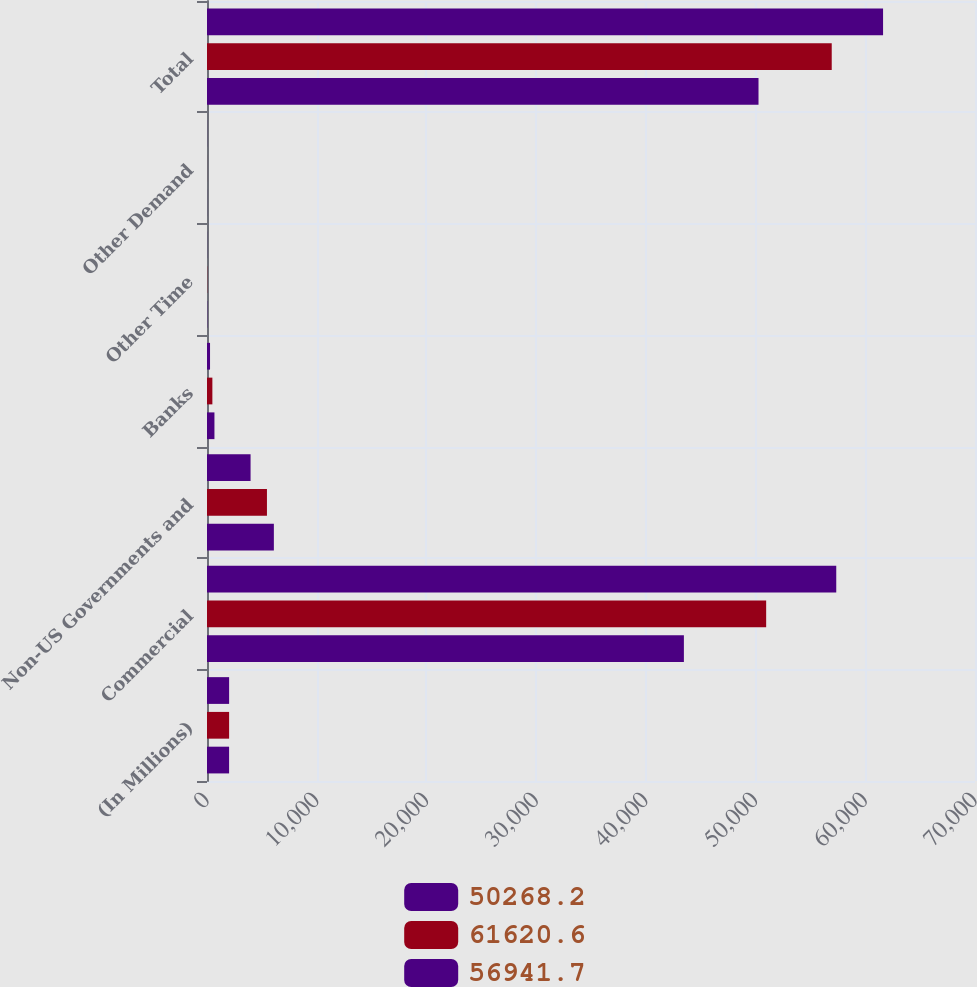Convert chart. <chart><loc_0><loc_0><loc_500><loc_500><stacked_bar_chart><ecel><fcel>(In Millions)<fcel>Commercial<fcel>Non-US Governments and<fcel>Banks<fcel>Other Time<fcel>Other Demand<fcel>Total<nl><fcel>50268.2<fcel>2016<fcel>57354<fcel>3971.8<fcel>276.6<fcel>9.4<fcel>8.8<fcel>61620.6<nl><fcel>61620.6<fcel>2015<fcel>50965.8<fcel>5464.3<fcel>489.5<fcel>18.2<fcel>3.9<fcel>56941.7<nl><fcel>56941.7<fcel>2014<fcel>43466.6<fcel>6094.6<fcel>678.5<fcel>21.9<fcel>6.6<fcel>50268.2<nl></chart> 